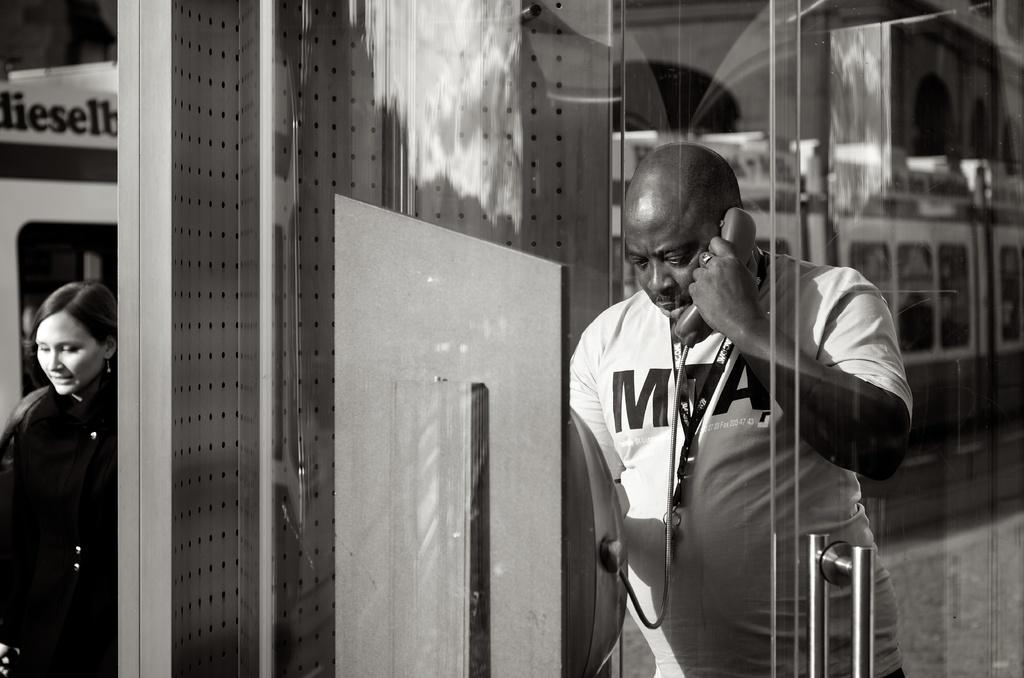What is the man on the right side of the image doing? The man is standing on the right side of the image and holding a telephone. Who else is present in the image? There is a woman standing on the left side of the image. What can be seen in the background of the image? There is a train visible in the background of the image. What emotion is the man expressing as he says good-bye to the woman in the image? There is no indication of any emotion or conversation between the man and the woman in the image. 